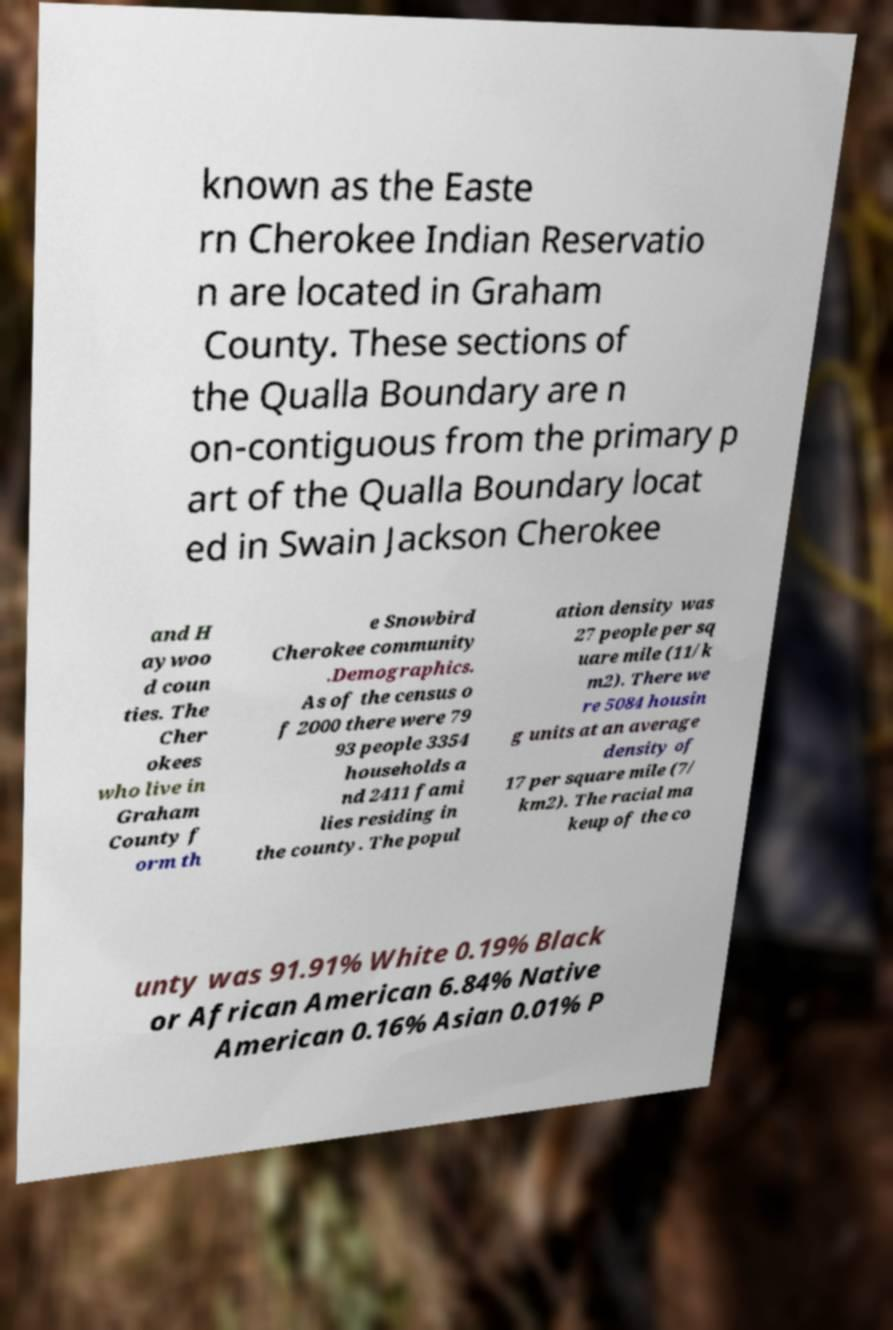Can you read and provide the text displayed in the image?This photo seems to have some interesting text. Can you extract and type it out for me? known as the Easte rn Cherokee Indian Reservatio n are located in Graham County. These sections of the Qualla Boundary are n on-contiguous from the primary p art of the Qualla Boundary locat ed in Swain Jackson Cherokee and H aywoo d coun ties. The Cher okees who live in Graham County f orm th e Snowbird Cherokee community .Demographics. As of the census o f 2000 there were 79 93 people 3354 households a nd 2411 fami lies residing in the county. The popul ation density was 27 people per sq uare mile (11/k m2). There we re 5084 housin g units at an average density of 17 per square mile (7/ km2). The racial ma keup of the co unty was 91.91% White 0.19% Black or African American 6.84% Native American 0.16% Asian 0.01% P 